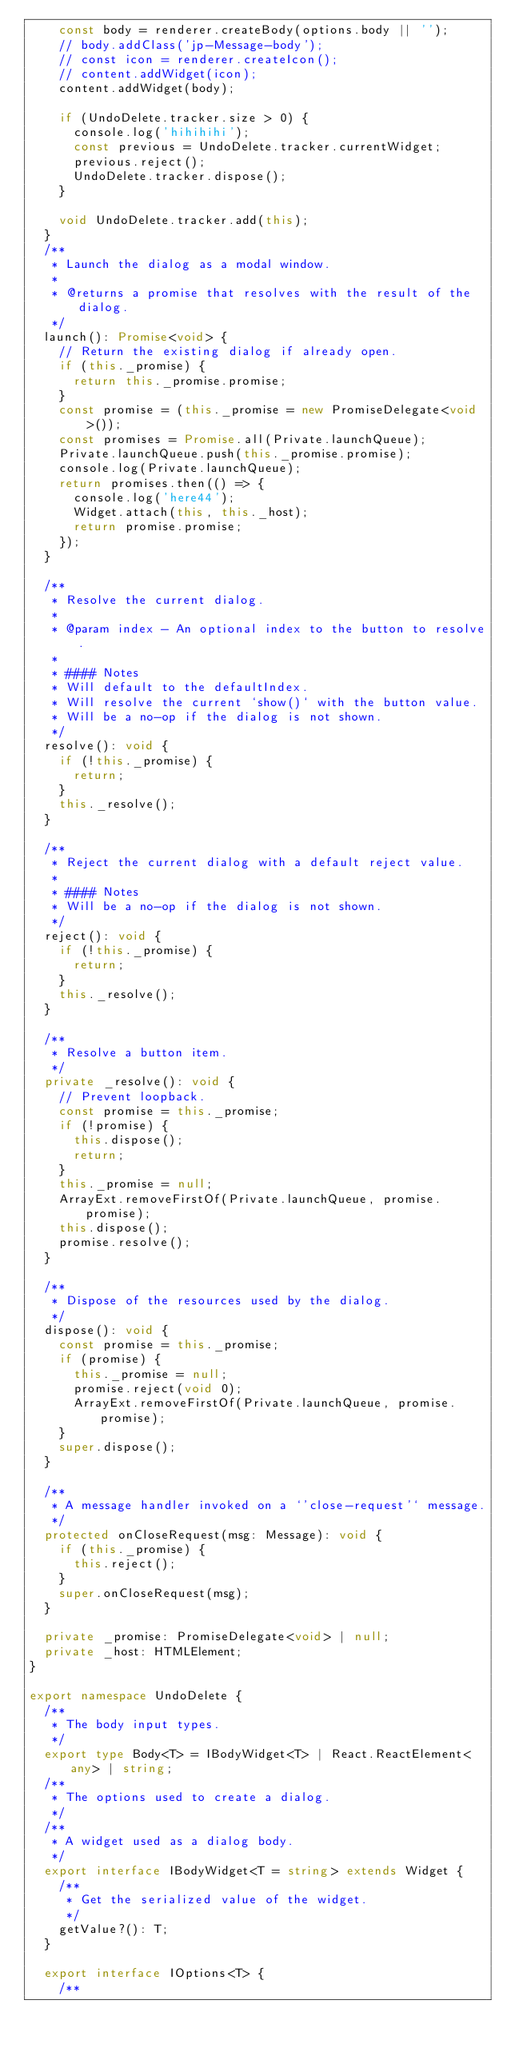<code> <loc_0><loc_0><loc_500><loc_500><_TypeScript_>    const body = renderer.createBody(options.body || '');
    // body.addClass('jp-Message-body');
    // const icon = renderer.createIcon();
    // content.addWidget(icon);
    content.addWidget(body);

    if (UndoDelete.tracker.size > 0) {
      console.log('hihihihi');
      const previous = UndoDelete.tracker.currentWidget;
      previous.reject();
      UndoDelete.tracker.dispose();
    }

    void UndoDelete.tracker.add(this);
  }
  /**
   * Launch the dialog as a modal window.
   *
   * @returns a promise that resolves with the result of the dialog.
   */
  launch(): Promise<void> {
    // Return the existing dialog if already open.
    if (this._promise) {
      return this._promise.promise;
    }
    const promise = (this._promise = new PromiseDelegate<void>());
    const promises = Promise.all(Private.launchQueue);
    Private.launchQueue.push(this._promise.promise);
    console.log(Private.launchQueue);
    return promises.then(() => {
      console.log('here44');
      Widget.attach(this, this._host);
      return promise.promise;
    });
  }

  /**
   * Resolve the current dialog.
   *
   * @param index - An optional index to the button to resolve.
   *
   * #### Notes
   * Will default to the defaultIndex.
   * Will resolve the current `show()` with the button value.
   * Will be a no-op if the dialog is not shown.
   */
  resolve(): void {
    if (!this._promise) {
      return;
    }
    this._resolve();
  }

  /**
   * Reject the current dialog with a default reject value.
   *
   * #### Notes
   * Will be a no-op if the dialog is not shown.
   */
  reject(): void {
    if (!this._promise) {
      return;
    }
    this._resolve();
  }

  /**
   * Resolve a button item.
   */
  private _resolve(): void {
    // Prevent loopback.
    const promise = this._promise;
    if (!promise) {
      this.dispose();
      return;
    }
    this._promise = null;
    ArrayExt.removeFirstOf(Private.launchQueue, promise.promise);
    this.dispose();
    promise.resolve();
  }

  /**
   * Dispose of the resources used by the dialog.
   */
  dispose(): void {
    const promise = this._promise;
    if (promise) {
      this._promise = null;
      promise.reject(void 0);
      ArrayExt.removeFirstOf(Private.launchQueue, promise.promise);
    }
    super.dispose();
  }

  /**
   * A message handler invoked on a `'close-request'` message.
   */
  protected onCloseRequest(msg: Message): void {
    if (this._promise) {
      this.reject();
    }
    super.onCloseRequest(msg);
  }

  private _promise: PromiseDelegate<void> | null;
  private _host: HTMLElement;
}

export namespace UndoDelete {
  /**
   * The body input types.
   */
  export type Body<T> = IBodyWidget<T> | React.ReactElement<any> | string;
  /**
   * The options used to create a dialog.
   */
  /**
   * A widget used as a dialog body.
   */
  export interface IBodyWidget<T = string> extends Widget {
    /**
     * Get the serialized value of the widget.
     */
    getValue?(): T;
  }

  export interface IOptions<T> {
    /**</code> 